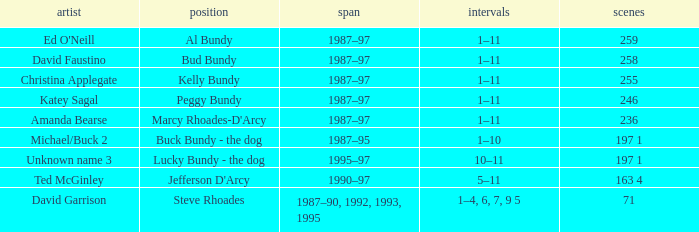How many years did the role of Steve Rhoades last? 1987–90, 1992, 1993, 1995. 